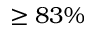Convert formula to latex. <formula><loc_0><loc_0><loc_500><loc_500>\geq 8 3 \%</formula> 